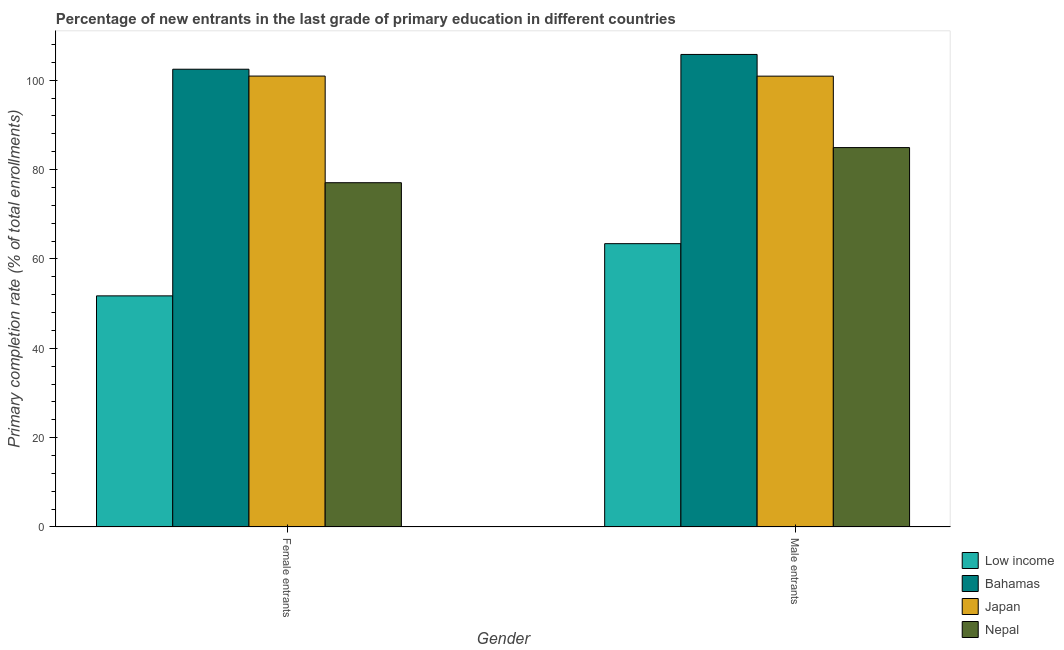How many different coloured bars are there?
Keep it short and to the point. 4. How many groups of bars are there?
Offer a terse response. 2. How many bars are there on the 1st tick from the left?
Make the answer very short. 4. What is the label of the 1st group of bars from the left?
Give a very brief answer. Female entrants. What is the primary completion rate of female entrants in Nepal?
Your answer should be compact. 77.05. Across all countries, what is the maximum primary completion rate of female entrants?
Make the answer very short. 102.45. Across all countries, what is the minimum primary completion rate of male entrants?
Your answer should be compact. 63.41. In which country was the primary completion rate of male entrants maximum?
Provide a short and direct response. Bahamas. What is the total primary completion rate of female entrants in the graph?
Provide a succinct answer. 332.15. What is the difference between the primary completion rate of male entrants in Nepal and that in Bahamas?
Provide a short and direct response. -20.84. What is the difference between the primary completion rate of male entrants in Low income and the primary completion rate of female entrants in Japan?
Give a very brief answer. -37.51. What is the average primary completion rate of female entrants per country?
Keep it short and to the point. 83.04. What is the difference between the primary completion rate of male entrants and primary completion rate of female entrants in Low income?
Your answer should be very brief. 11.68. What is the ratio of the primary completion rate of male entrants in Low income to that in Nepal?
Make the answer very short. 0.75. In how many countries, is the primary completion rate of female entrants greater than the average primary completion rate of female entrants taken over all countries?
Keep it short and to the point. 2. What does the 2nd bar from the left in Female entrants represents?
Give a very brief answer. Bahamas. What does the 2nd bar from the right in Male entrants represents?
Offer a very short reply. Japan. Are all the bars in the graph horizontal?
Offer a very short reply. No. How many countries are there in the graph?
Provide a short and direct response. 4. Does the graph contain grids?
Keep it short and to the point. No. Where does the legend appear in the graph?
Offer a terse response. Bottom right. How many legend labels are there?
Offer a terse response. 4. What is the title of the graph?
Offer a terse response. Percentage of new entrants in the last grade of primary education in different countries. What is the label or title of the X-axis?
Your response must be concise. Gender. What is the label or title of the Y-axis?
Your answer should be compact. Primary completion rate (% of total enrollments). What is the Primary completion rate (% of total enrollments) of Low income in Female entrants?
Ensure brevity in your answer.  51.73. What is the Primary completion rate (% of total enrollments) of Bahamas in Female entrants?
Provide a short and direct response. 102.45. What is the Primary completion rate (% of total enrollments) in Japan in Female entrants?
Your answer should be very brief. 100.92. What is the Primary completion rate (% of total enrollments) of Nepal in Female entrants?
Your answer should be compact. 77.05. What is the Primary completion rate (% of total enrollments) in Low income in Male entrants?
Offer a terse response. 63.41. What is the Primary completion rate (% of total enrollments) of Bahamas in Male entrants?
Your response must be concise. 105.76. What is the Primary completion rate (% of total enrollments) in Japan in Male entrants?
Your answer should be very brief. 100.9. What is the Primary completion rate (% of total enrollments) in Nepal in Male entrants?
Provide a succinct answer. 84.91. Across all Gender, what is the maximum Primary completion rate (% of total enrollments) in Low income?
Offer a very short reply. 63.41. Across all Gender, what is the maximum Primary completion rate (% of total enrollments) in Bahamas?
Your answer should be very brief. 105.76. Across all Gender, what is the maximum Primary completion rate (% of total enrollments) of Japan?
Provide a short and direct response. 100.92. Across all Gender, what is the maximum Primary completion rate (% of total enrollments) of Nepal?
Provide a succinct answer. 84.91. Across all Gender, what is the minimum Primary completion rate (% of total enrollments) in Low income?
Give a very brief answer. 51.73. Across all Gender, what is the minimum Primary completion rate (% of total enrollments) of Bahamas?
Offer a terse response. 102.45. Across all Gender, what is the minimum Primary completion rate (% of total enrollments) in Japan?
Provide a succinct answer. 100.9. Across all Gender, what is the minimum Primary completion rate (% of total enrollments) in Nepal?
Provide a succinct answer. 77.05. What is the total Primary completion rate (% of total enrollments) in Low income in the graph?
Your answer should be very brief. 115.14. What is the total Primary completion rate (% of total enrollments) of Bahamas in the graph?
Give a very brief answer. 208.21. What is the total Primary completion rate (% of total enrollments) of Japan in the graph?
Give a very brief answer. 201.82. What is the total Primary completion rate (% of total enrollments) of Nepal in the graph?
Provide a short and direct response. 161.97. What is the difference between the Primary completion rate (% of total enrollments) of Low income in Female entrants and that in Male entrants?
Make the answer very short. -11.68. What is the difference between the Primary completion rate (% of total enrollments) in Bahamas in Female entrants and that in Male entrants?
Make the answer very short. -3.31. What is the difference between the Primary completion rate (% of total enrollments) in Japan in Female entrants and that in Male entrants?
Your answer should be very brief. 0.02. What is the difference between the Primary completion rate (% of total enrollments) of Nepal in Female entrants and that in Male entrants?
Make the answer very short. -7.86. What is the difference between the Primary completion rate (% of total enrollments) in Low income in Female entrants and the Primary completion rate (% of total enrollments) in Bahamas in Male entrants?
Your answer should be very brief. -54.03. What is the difference between the Primary completion rate (% of total enrollments) of Low income in Female entrants and the Primary completion rate (% of total enrollments) of Japan in Male entrants?
Ensure brevity in your answer.  -49.18. What is the difference between the Primary completion rate (% of total enrollments) in Low income in Female entrants and the Primary completion rate (% of total enrollments) in Nepal in Male entrants?
Give a very brief answer. -33.19. What is the difference between the Primary completion rate (% of total enrollments) in Bahamas in Female entrants and the Primary completion rate (% of total enrollments) in Japan in Male entrants?
Your response must be concise. 1.55. What is the difference between the Primary completion rate (% of total enrollments) of Bahamas in Female entrants and the Primary completion rate (% of total enrollments) of Nepal in Male entrants?
Your response must be concise. 17.54. What is the difference between the Primary completion rate (% of total enrollments) in Japan in Female entrants and the Primary completion rate (% of total enrollments) in Nepal in Male entrants?
Give a very brief answer. 16. What is the average Primary completion rate (% of total enrollments) of Low income per Gender?
Provide a succinct answer. 57.57. What is the average Primary completion rate (% of total enrollments) in Bahamas per Gender?
Make the answer very short. 104.1. What is the average Primary completion rate (% of total enrollments) in Japan per Gender?
Provide a succinct answer. 100.91. What is the average Primary completion rate (% of total enrollments) in Nepal per Gender?
Your answer should be very brief. 80.98. What is the difference between the Primary completion rate (% of total enrollments) in Low income and Primary completion rate (% of total enrollments) in Bahamas in Female entrants?
Ensure brevity in your answer.  -50.72. What is the difference between the Primary completion rate (% of total enrollments) of Low income and Primary completion rate (% of total enrollments) of Japan in Female entrants?
Offer a very short reply. -49.19. What is the difference between the Primary completion rate (% of total enrollments) in Low income and Primary completion rate (% of total enrollments) in Nepal in Female entrants?
Provide a succinct answer. -25.33. What is the difference between the Primary completion rate (% of total enrollments) in Bahamas and Primary completion rate (% of total enrollments) in Japan in Female entrants?
Your response must be concise. 1.53. What is the difference between the Primary completion rate (% of total enrollments) of Bahamas and Primary completion rate (% of total enrollments) of Nepal in Female entrants?
Offer a very short reply. 25.4. What is the difference between the Primary completion rate (% of total enrollments) of Japan and Primary completion rate (% of total enrollments) of Nepal in Female entrants?
Your response must be concise. 23.87. What is the difference between the Primary completion rate (% of total enrollments) of Low income and Primary completion rate (% of total enrollments) of Bahamas in Male entrants?
Give a very brief answer. -42.35. What is the difference between the Primary completion rate (% of total enrollments) of Low income and Primary completion rate (% of total enrollments) of Japan in Male entrants?
Your answer should be compact. -37.49. What is the difference between the Primary completion rate (% of total enrollments) in Low income and Primary completion rate (% of total enrollments) in Nepal in Male entrants?
Provide a short and direct response. -21.5. What is the difference between the Primary completion rate (% of total enrollments) in Bahamas and Primary completion rate (% of total enrollments) in Japan in Male entrants?
Your answer should be compact. 4.85. What is the difference between the Primary completion rate (% of total enrollments) of Bahamas and Primary completion rate (% of total enrollments) of Nepal in Male entrants?
Your answer should be compact. 20.84. What is the difference between the Primary completion rate (% of total enrollments) in Japan and Primary completion rate (% of total enrollments) in Nepal in Male entrants?
Your response must be concise. 15.99. What is the ratio of the Primary completion rate (% of total enrollments) in Low income in Female entrants to that in Male entrants?
Make the answer very short. 0.82. What is the ratio of the Primary completion rate (% of total enrollments) of Bahamas in Female entrants to that in Male entrants?
Provide a succinct answer. 0.97. What is the ratio of the Primary completion rate (% of total enrollments) of Nepal in Female entrants to that in Male entrants?
Provide a short and direct response. 0.91. What is the difference between the highest and the second highest Primary completion rate (% of total enrollments) in Low income?
Keep it short and to the point. 11.68. What is the difference between the highest and the second highest Primary completion rate (% of total enrollments) in Bahamas?
Your answer should be very brief. 3.31. What is the difference between the highest and the second highest Primary completion rate (% of total enrollments) in Japan?
Give a very brief answer. 0.02. What is the difference between the highest and the second highest Primary completion rate (% of total enrollments) in Nepal?
Ensure brevity in your answer.  7.86. What is the difference between the highest and the lowest Primary completion rate (% of total enrollments) in Low income?
Provide a short and direct response. 11.68. What is the difference between the highest and the lowest Primary completion rate (% of total enrollments) in Bahamas?
Your answer should be very brief. 3.31. What is the difference between the highest and the lowest Primary completion rate (% of total enrollments) of Japan?
Keep it short and to the point. 0.02. What is the difference between the highest and the lowest Primary completion rate (% of total enrollments) of Nepal?
Keep it short and to the point. 7.86. 